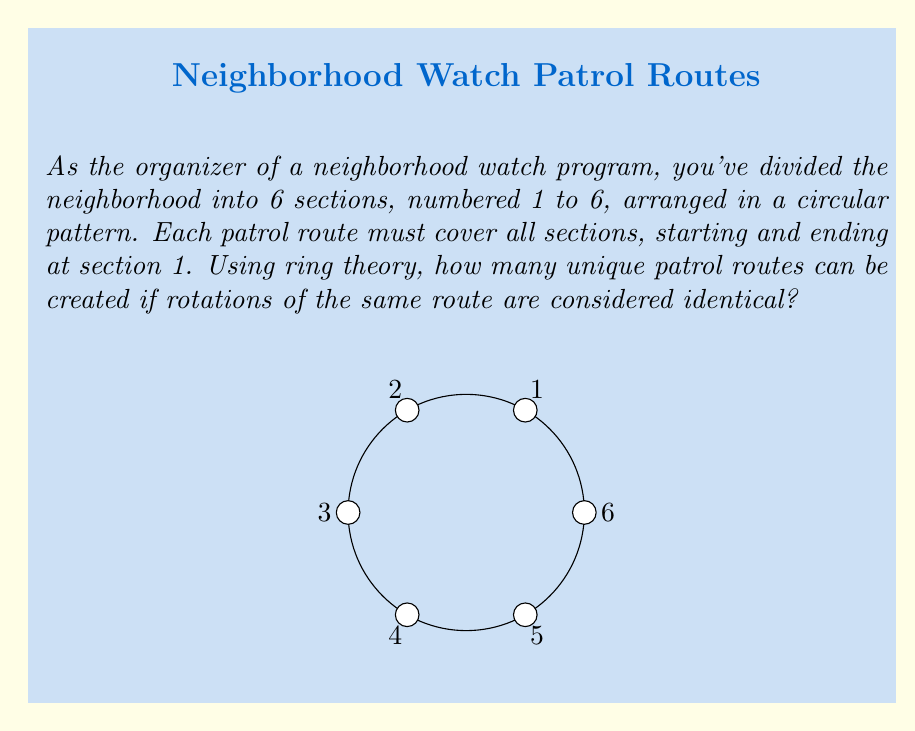Can you solve this math problem? Let's approach this step-by-step using concepts from ring theory:

1) First, we need to recognize that this problem is equivalent to finding the number of elements in the dihedral group $D_6$ (the symmetry group of a regular hexagon).

2) In ring theory, the dihedral group $D_6$ has order $2n = 12$, where $n = 6$ is the number of sections.

3) However, we're only interested in rotations, not reflections. The number of rotations in $D_6$ is equal to $n = 6$.

4) Now, we need to consider that all routes start and end at section 1. This means we're actually looking at $(6-1)! = 5!$ permutations of the remaining 5 sections.

5) But, rotations of the same route are considered identical. This means we need to divide our total number of permutations by the number of rotations:

   $$\frac{5!}{6} = \frac{120}{6} = 20$$

Therefore, there are 20 unique patrol routes.
Answer: 20 unique patrol routes 